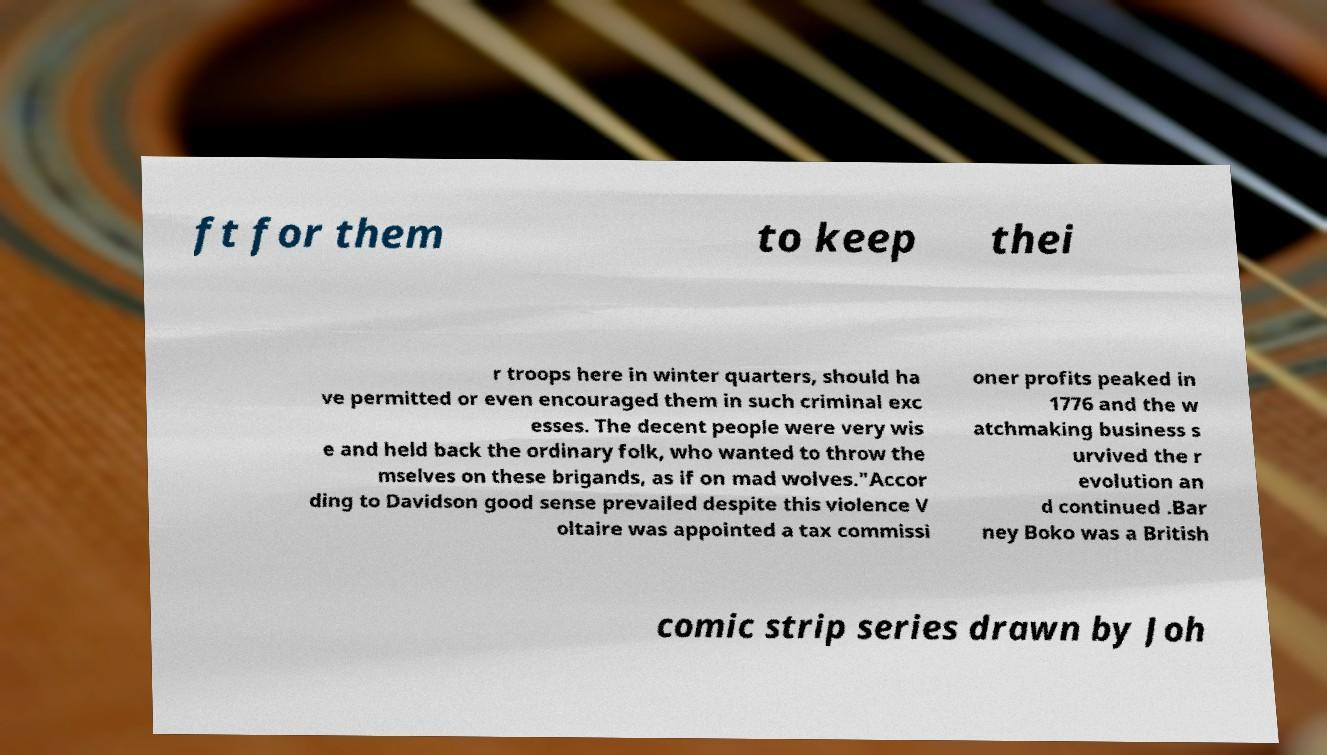Could you extract and type out the text from this image? ft for them to keep thei r troops here in winter quarters, should ha ve permitted or even encouraged them in such criminal exc esses. The decent people were very wis e and held back the ordinary folk, who wanted to throw the mselves on these brigands, as if on mad wolves."Accor ding to Davidson good sense prevailed despite this violence V oltaire was appointed a tax commissi oner profits peaked in 1776 and the w atchmaking business s urvived the r evolution an d continued .Bar ney Boko was a British comic strip series drawn by Joh 